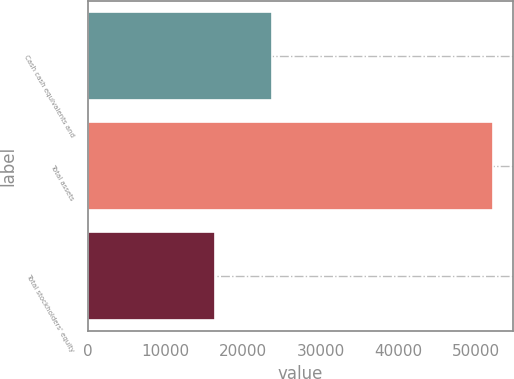Convert chart. <chart><loc_0><loc_0><loc_500><loc_500><bar_chart><fcel>Cash cash equivalents and<fcel>Total assets<fcel>Total stockholders' equity<nl><fcel>23663<fcel>52207<fcel>16367<nl></chart> 